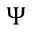Convert formula to latex. <formula><loc_0><loc_0><loc_500><loc_500>\Psi</formula> 